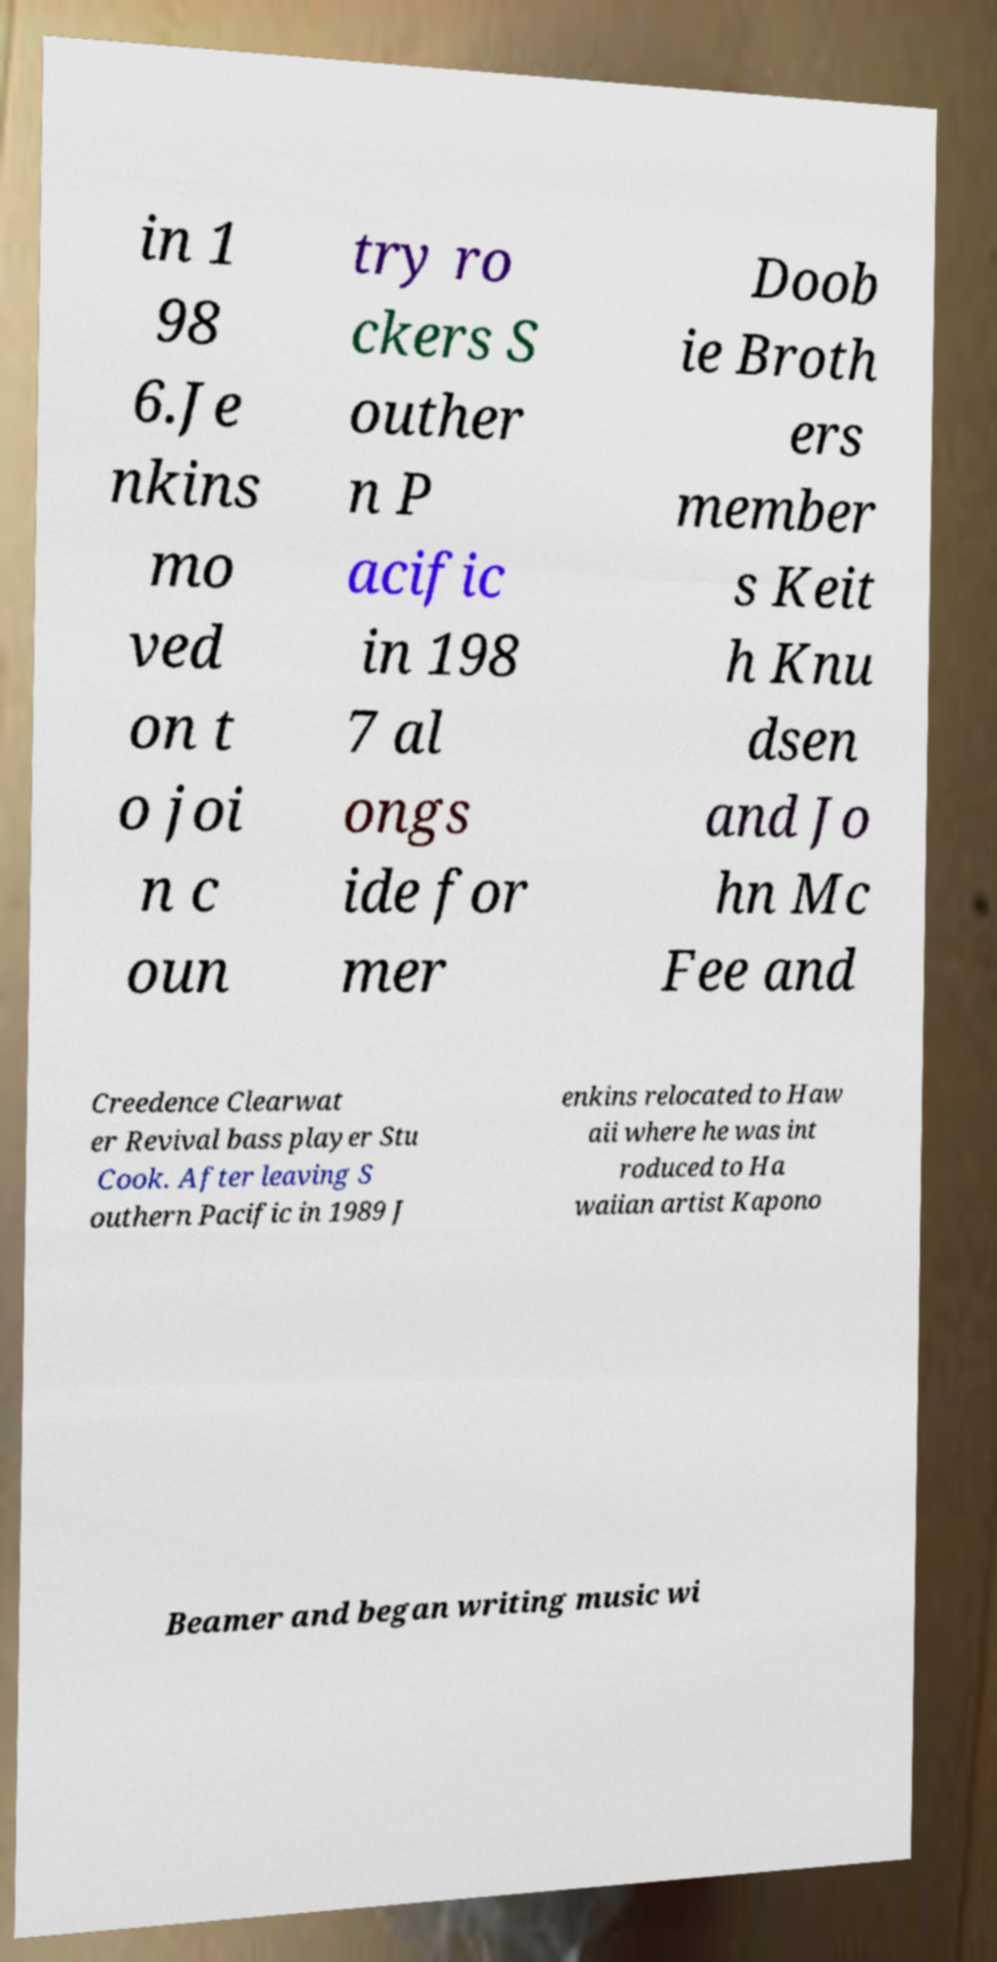For documentation purposes, I need the text within this image transcribed. Could you provide that? in 1 98 6.Je nkins mo ved on t o joi n c oun try ro ckers S outher n P acific in 198 7 al ongs ide for mer Doob ie Broth ers member s Keit h Knu dsen and Jo hn Mc Fee and Creedence Clearwat er Revival bass player Stu Cook. After leaving S outhern Pacific in 1989 J enkins relocated to Haw aii where he was int roduced to Ha waiian artist Kapono Beamer and began writing music wi 